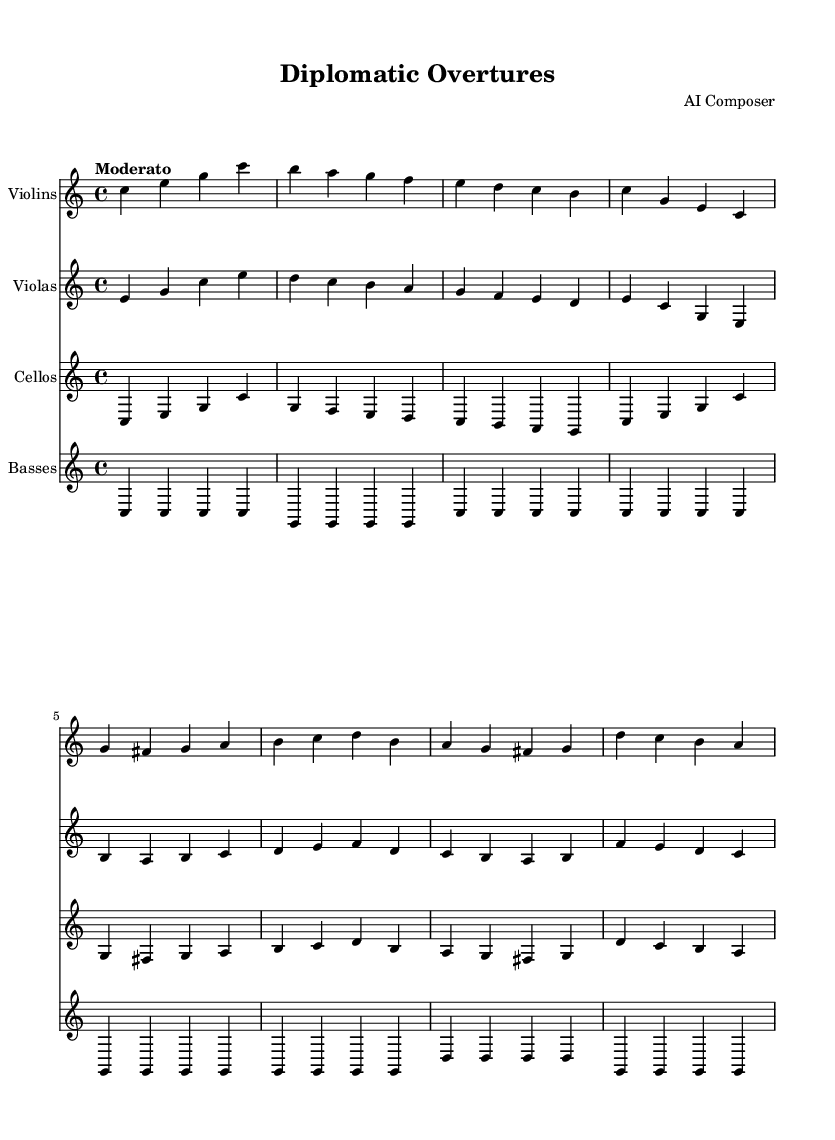What is the key signature of this music? The key signature is indicated at the beginning of the score. It shows no sharps or flats, which means it is in C major.
Answer: C major What is the time signature of this music? The time signature is located right after the key signature at the beginning of the score. It is written as 4/4, indicating four beats per measure with a quarter note getting one beat.
Answer: 4/4 What is the tempo marking for this piece? The tempo marking is stated at the beginning of the score, specifying how fast the piece should be played. It reads "Moderato," which means moderately.
Answer: Moderato How many measures are there in the violins' part? To find the number of measures, one can count the groups of music notation separated by vertical lines (barlines) in the violins' part. There are eight measures.
Answer: Eight Which instruments are included in this orchestral piece? The list of instruments can be found at the beginning of each staff, where each instrument's name is labeled. The instruments are Violins, Violas, Cellos, and Basses.
Answer: Violins, Violas, Cellos, Basses What is the highest note played in the violins' part? To determine the highest note, look for the note that appears highest on the staff; in this case, the highest note is g' (G in the octave above middle C) in the sequence.
Answer: g' What is the rhythmic pattern used primarily in the cellos' part? The rhythmic pattern can be found by observing how the notes are grouped in the measures. The predominant rhythm in the cellos' part consists of quarter notes, with few variations.
Answer: Quarter notes 